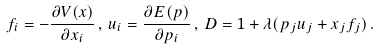Convert formula to latex. <formula><loc_0><loc_0><loc_500><loc_500>f _ { i } = - \frac { \partial V ( x ) } { \partial x _ { i } } \, , \, u _ { i } = \frac { \partial E ( p ) } { \partial p _ { i } } \, , \, D = 1 + \lambda ( p _ { j } u _ { j } + x _ { j } f _ { j } ) \, .</formula> 